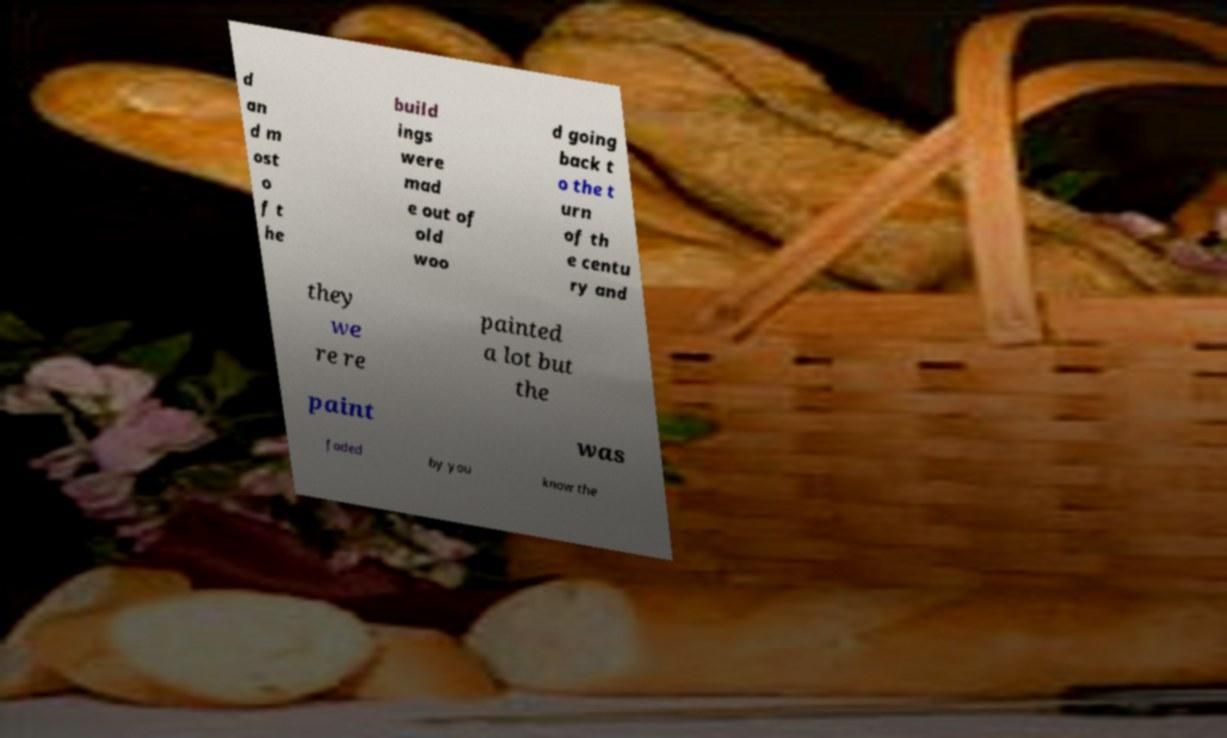I need the written content from this picture converted into text. Can you do that? d an d m ost o f t he build ings were mad e out of old woo d going back t o the t urn of th e centu ry and they we re re painted a lot but the paint was faded by you know the 